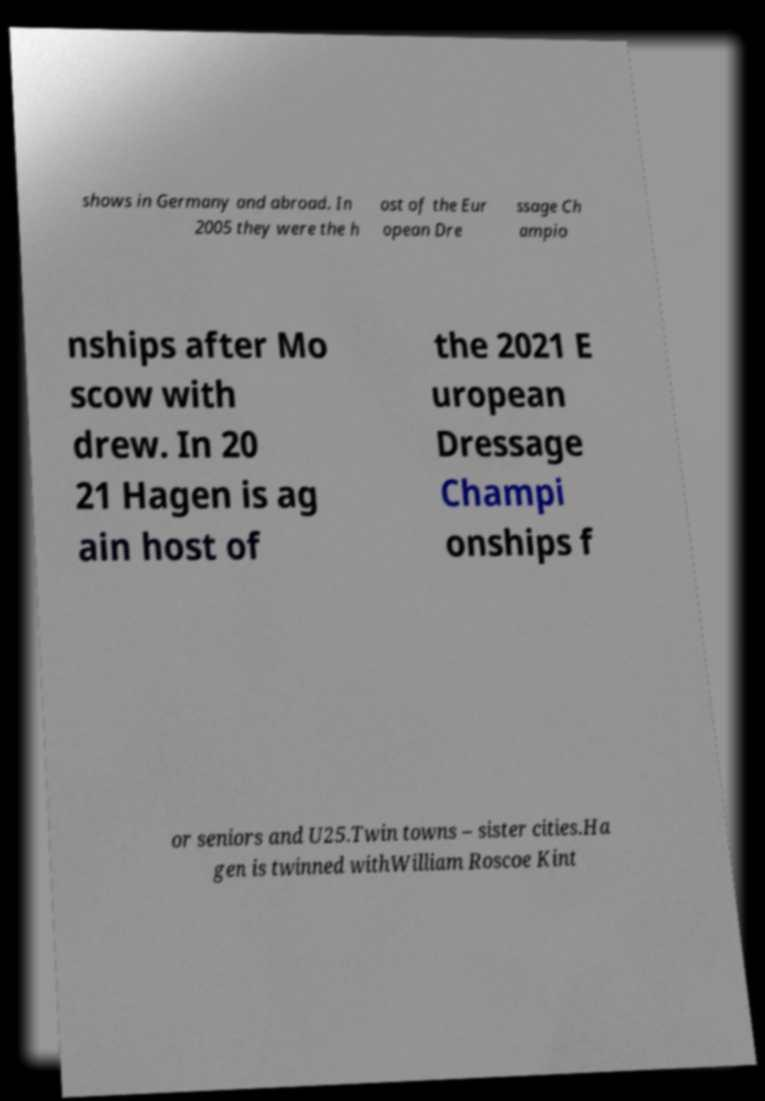Could you extract and type out the text from this image? shows in Germany and abroad. In 2005 they were the h ost of the Eur opean Dre ssage Ch ampio nships after Mo scow with drew. In 20 21 Hagen is ag ain host of the 2021 E uropean Dressage Champi onships f or seniors and U25.Twin towns – sister cities.Ha gen is twinned withWilliam Roscoe Kint 